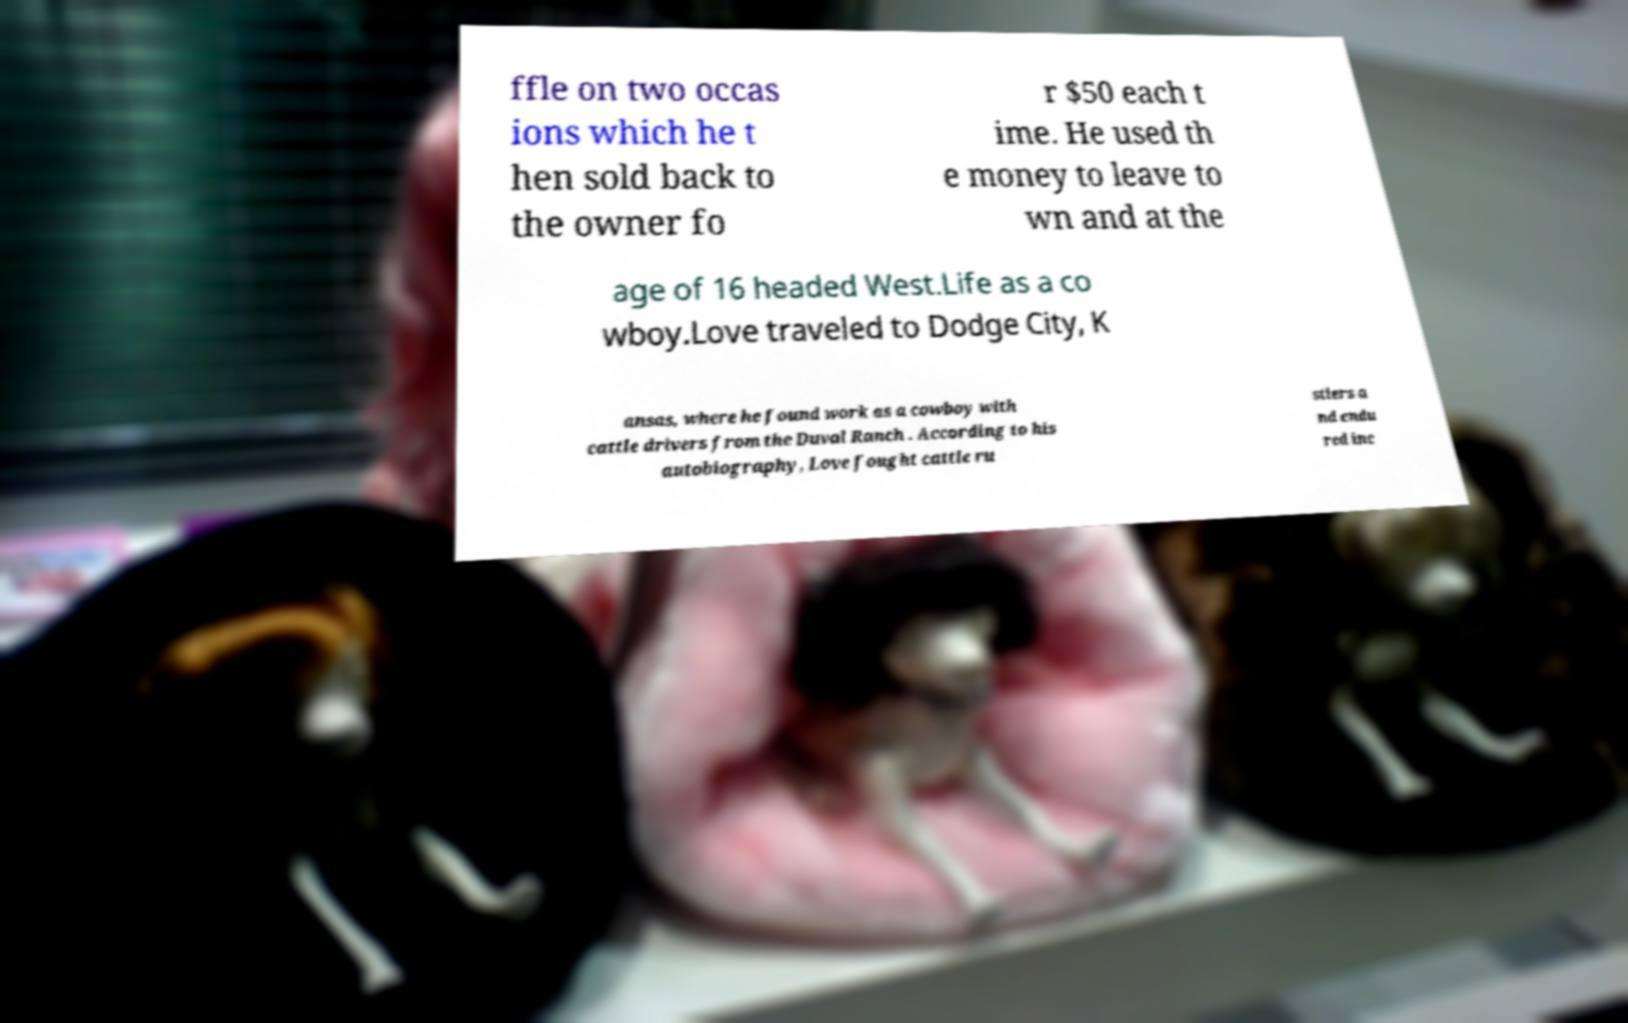There's text embedded in this image that I need extracted. Can you transcribe it verbatim? ffle on two occas ions which he t hen sold back to the owner fo r $50 each t ime. He used th e money to leave to wn and at the age of 16 headed West.Life as a co wboy.Love traveled to Dodge City, K ansas, where he found work as a cowboy with cattle drivers from the Duval Ranch . According to his autobiography, Love fought cattle ru stlers a nd endu red inc 